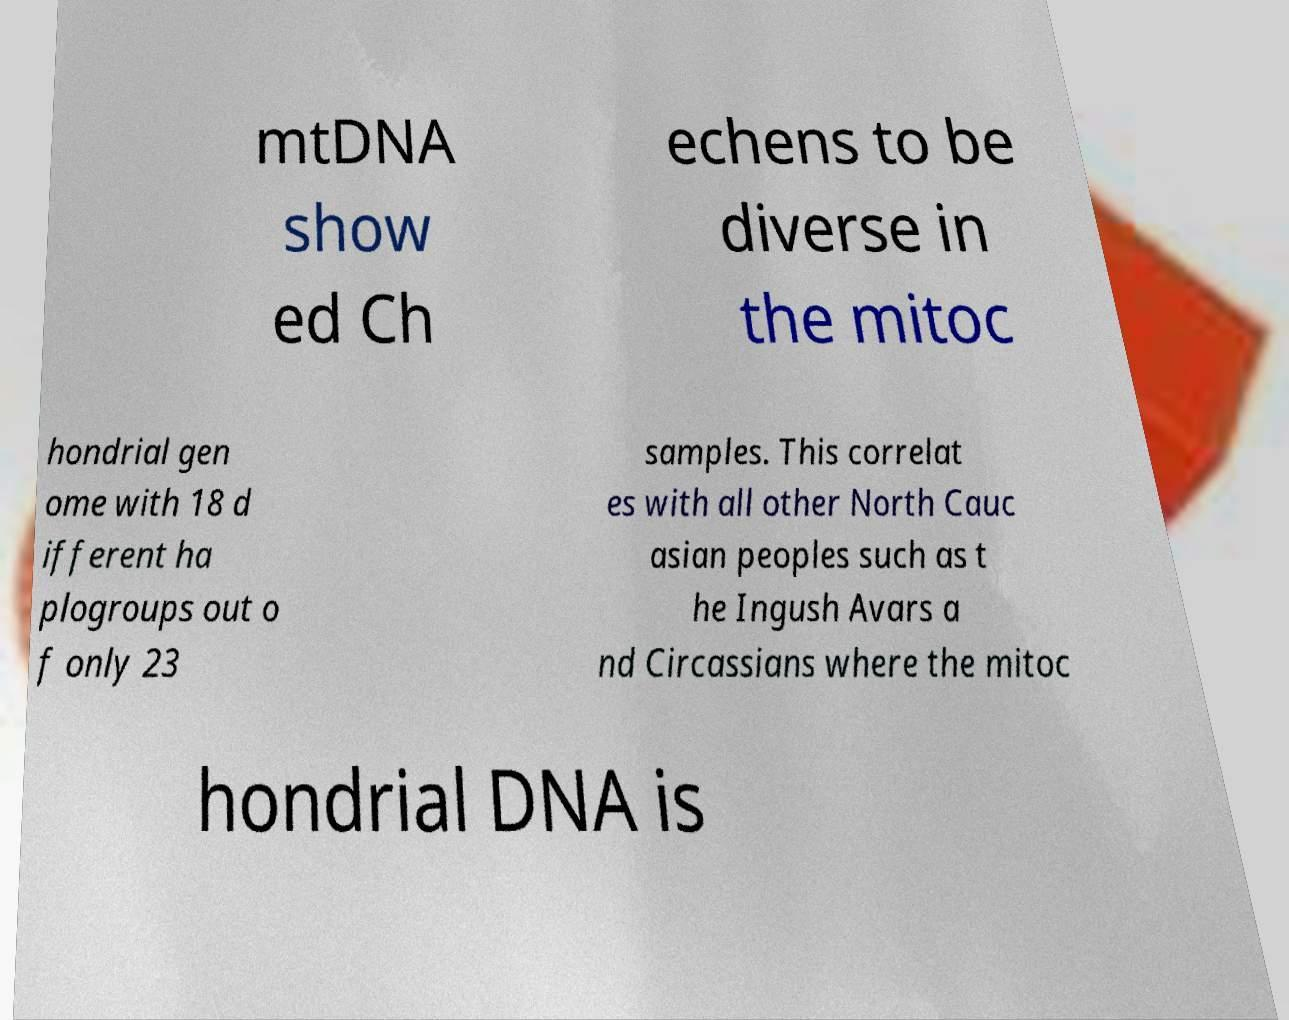I need the written content from this picture converted into text. Can you do that? mtDNA show ed Ch echens to be diverse in the mitoc hondrial gen ome with 18 d ifferent ha plogroups out o f only 23 samples. This correlat es with all other North Cauc asian peoples such as t he Ingush Avars a nd Circassians where the mitoc hondrial DNA is 